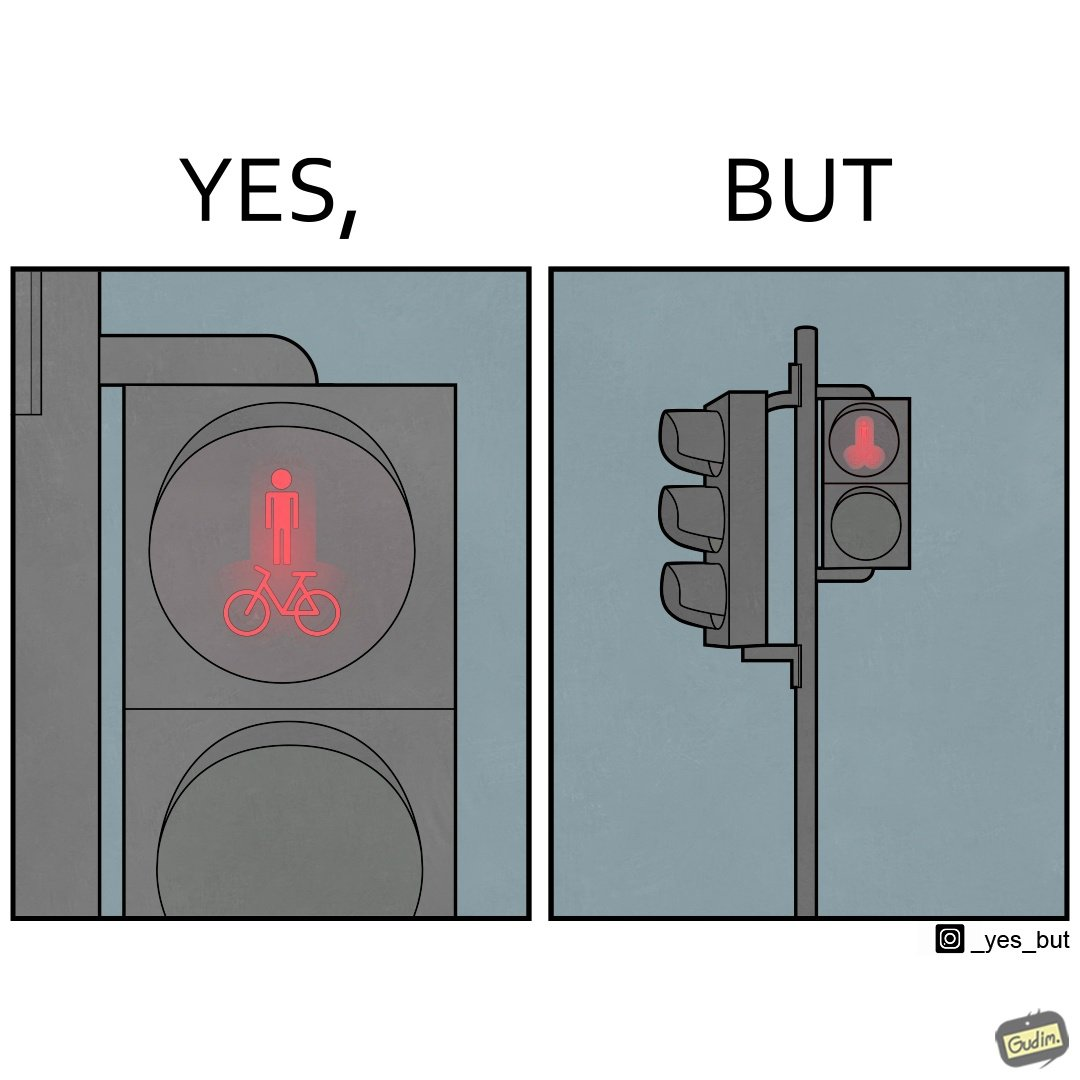Is this image satirical or non-satirical? Yes, this image is satirical. 